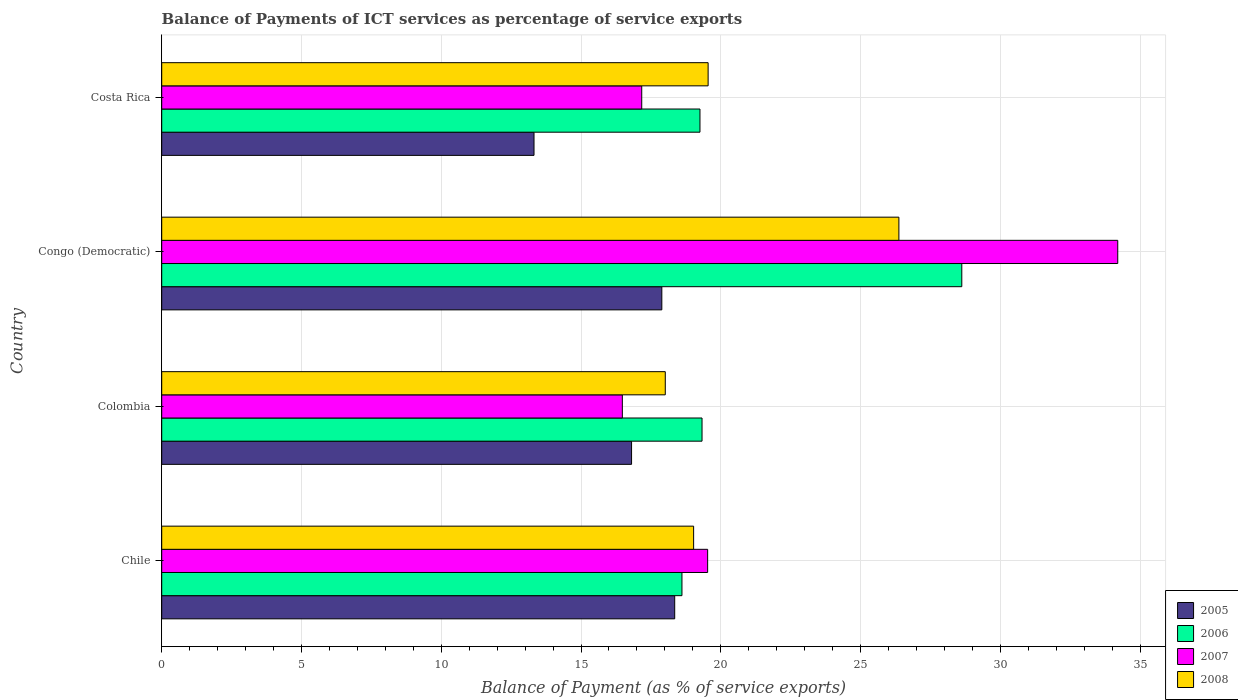How many groups of bars are there?
Give a very brief answer. 4. Are the number of bars per tick equal to the number of legend labels?
Provide a succinct answer. Yes. Are the number of bars on each tick of the Y-axis equal?
Offer a very short reply. Yes. How many bars are there on the 2nd tick from the bottom?
Provide a short and direct response. 4. What is the label of the 2nd group of bars from the top?
Your answer should be very brief. Congo (Democratic). In how many cases, is the number of bars for a given country not equal to the number of legend labels?
Your response must be concise. 0. What is the balance of payments of ICT services in 2006 in Colombia?
Offer a terse response. 19.33. Across all countries, what is the maximum balance of payments of ICT services in 2008?
Provide a succinct answer. 26.37. Across all countries, what is the minimum balance of payments of ICT services in 2008?
Offer a terse response. 18.01. In which country was the balance of payments of ICT services in 2006 maximum?
Offer a terse response. Congo (Democratic). What is the total balance of payments of ICT services in 2005 in the graph?
Provide a short and direct response. 66.37. What is the difference between the balance of payments of ICT services in 2008 in Chile and that in Congo (Democratic)?
Provide a succinct answer. -7.34. What is the difference between the balance of payments of ICT services in 2005 in Congo (Democratic) and the balance of payments of ICT services in 2006 in Costa Rica?
Your answer should be very brief. -1.36. What is the average balance of payments of ICT services in 2007 per country?
Provide a succinct answer. 21.84. What is the difference between the balance of payments of ICT services in 2005 and balance of payments of ICT services in 2006 in Congo (Democratic)?
Your answer should be very brief. -10.73. What is the ratio of the balance of payments of ICT services in 2006 in Chile to that in Costa Rica?
Ensure brevity in your answer.  0.97. Is the balance of payments of ICT services in 2008 in Congo (Democratic) less than that in Costa Rica?
Provide a short and direct response. No. What is the difference between the highest and the second highest balance of payments of ICT services in 2007?
Provide a succinct answer. 14.67. What is the difference between the highest and the lowest balance of payments of ICT services in 2008?
Offer a very short reply. 8.36. In how many countries, is the balance of payments of ICT services in 2008 greater than the average balance of payments of ICT services in 2008 taken over all countries?
Offer a terse response. 1. Is the sum of the balance of payments of ICT services in 2008 in Chile and Colombia greater than the maximum balance of payments of ICT services in 2007 across all countries?
Keep it short and to the point. Yes. What does the 1st bar from the top in Congo (Democratic) represents?
Make the answer very short. 2008. What does the 3rd bar from the bottom in Colombia represents?
Give a very brief answer. 2007. How many bars are there?
Provide a succinct answer. 16. Are all the bars in the graph horizontal?
Keep it short and to the point. Yes. How many countries are there in the graph?
Offer a very short reply. 4. Are the values on the major ticks of X-axis written in scientific E-notation?
Make the answer very short. No. Does the graph contain any zero values?
Your answer should be very brief. No. How many legend labels are there?
Keep it short and to the point. 4. What is the title of the graph?
Keep it short and to the point. Balance of Payments of ICT services as percentage of service exports. What is the label or title of the X-axis?
Keep it short and to the point. Balance of Payment (as % of service exports). What is the Balance of Payment (as % of service exports) of 2005 in Chile?
Offer a very short reply. 18.35. What is the Balance of Payment (as % of service exports) in 2006 in Chile?
Provide a succinct answer. 18.61. What is the Balance of Payment (as % of service exports) in 2007 in Chile?
Provide a succinct answer. 19.53. What is the Balance of Payment (as % of service exports) in 2008 in Chile?
Provide a short and direct response. 19.03. What is the Balance of Payment (as % of service exports) of 2005 in Colombia?
Provide a succinct answer. 16.81. What is the Balance of Payment (as % of service exports) in 2006 in Colombia?
Provide a short and direct response. 19.33. What is the Balance of Payment (as % of service exports) in 2007 in Colombia?
Provide a succinct answer. 16.48. What is the Balance of Payment (as % of service exports) of 2008 in Colombia?
Offer a very short reply. 18.01. What is the Balance of Payment (as % of service exports) of 2005 in Congo (Democratic)?
Offer a terse response. 17.89. What is the Balance of Payment (as % of service exports) in 2006 in Congo (Democratic)?
Your response must be concise. 28.62. What is the Balance of Payment (as % of service exports) in 2007 in Congo (Democratic)?
Provide a short and direct response. 34.2. What is the Balance of Payment (as % of service exports) in 2008 in Congo (Democratic)?
Your answer should be very brief. 26.37. What is the Balance of Payment (as % of service exports) in 2005 in Costa Rica?
Your response must be concise. 13.32. What is the Balance of Payment (as % of service exports) of 2006 in Costa Rica?
Ensure brevity in your answer.  19.25. What is the Balance of Payment (as % of service exports) in 2007 in Costa Rica?
Your response must be concise. 17.17. What is the Balance of Payment (as % of service exports) in 2008 in Costa Rica?
Provide a short and direct response. 19.55. Across all countries, what is the maximum Balance of Payment (as % of service exports) in 2005?
Ensure brevity in your answer.  18.35. Across all countries, what is the maximum Balance of Payment (as % of service exports) in 2006?
Your response must be concise. 28.62. Across all countries, what is the maximum Balance of Payment (as % of service exports) of 2007?
Ensure brevity in your answer.  34.2. Across all countries, what is the maximum Balance of Payment (as % of service exports) of 2008?
Your answer should be very brief. 26.37. Across all countries, what is the minimum Balance of Payment (as % of service exports) in 2005?
Your answer should be compact. 13.32. Across all countries, what is the minimum Balance of Payment (as % of service exports) in 2006?
Give a very brief answer. 18.61. Across all countries, what is the minimum Balance of Payment (as % of service exports) of 2007?
Ensure brevity in your answer.  16.48. Across all countries, what is the minimum Balance of Payment (as % of service exports) in 2008?
Offer a terse response. 18.01. What is the total Balance of Payment (as % of service exports) of 2005 in the graph?
Keep it short and to the point. 66.37. What is the total Balance of Payment (as % of service exports) of 2006 in the graph?
Keep it short and to the point. 85.81. What is the total Balance of Payment (as % of service exports) in 2007 in the graph?
Offer a very short reply. 87.38. What is the total Balance of Payment (as % of service exports) in 2008 in the graph?
Keep it short and to the point. 82.96. What is the difference between the Balance of Payment (as % of service exports) of 2005 in Chile and that in Colombia?
Make the answer very short. 1.54. What is the difference between the Balance of Payment (as % of service exports) of 2006 in Chile and that in Colombia?
Your response must be concise. -0.72. What is the difference between the Balance of Payment (as % of service exports) in 2007 in Chile and that in Colombia?
Offer a terse response. 3.05. What is the difference between the Balance of Payment (as % of service exports) of 2008 in Chile and that in Colombia?
Keep it short and to the point. 1.01. What is the difference between the Balance of Payment (as % of service exports) of 2005 in Chile and that in Congo (Democratic)?
Make the answer very short. 0.46. What is the difference between the Balance of Payment (as % of service exports) of 2006 in Chile and that in Congo (Democratic)?
Your response must be concise. -10.01. What is the difference between the Balance of Payment (as % of service exports) in 2007 in Chile and that in Congo (Democratic)?
Keep it short and to the point. -14.67. What is the difference between the Balance of Payment (as % of service exports) of 2008 in Chile and that in Congo (Democratic)?
Ensure brevity in your answer.  -7.34. What is the difference between the Balance of Payment (as % of service exports) in 2005 in Chile and that in Costa Rica?
Your answer should be compact. 5.03. What is the difference between the Balance of Payment (as % of service exports) of 2006 in Chile and that in Costa Rica?
Ensure brevity in your answer.  -0.64. What is the difference between the Balance of Payment (as % of service exports) of 2007 in Chile and that in Costa Rica?
Give a very brief answer. 2.36. What is the difference between the Balance of Payment (as % of service exports) of 2008 in Chile and that in Costa Rica?
Your answer should be compact. -0.52. What is the difference between the Balance of Payment (as % of service exports) of 2005 in Colombia and that in Congo (Democratic)?
Provide a succinct answer. -1.08. What is the difference between the Balance of Payment (as % of service exports) of 2006 in Colombia and that in Congo (Democratic)?
Offer a terse response. -9.29. What is the difference between the Balance of Payment (as % of service exports) of 2007 in Colombia and that in Congo (Democratic)?
Provide a short and direct response. -17.72. What is the difference between the Balance of Payment (as % of service exports) of 2008 in Colombia and that in Congo (Democratic)?
Give a very brief answer. -8.36. What is the difference between the Balance of Payment (as % of service exports) in 2005 in Colombia and that in Costa Rica?
Ensure brevity in your answer.  3.49. What is the difference between the Balance of Payment (as % of service exports) of 2006 in Colombia and that in Costa Rica?
Your answer should be very brief. 0.07. What is the difference between the Balance of Payment (as % of service exports) in 2007 in Colombia and that in Costa Rica?
Your response must be concise. -0.69. What is the difference between the Balance of Payment (as % of service exports) in 2008 in Colombia and that in Costa Rica?
Provide a succinct answer. -1.53. What is the difference between the Balance of Payment (as % of service exports) of 2005 in Congo (Democratic) and that in Costa Rica?
Make the answer very short. 4.57. What is the difference between the Balance of Payment (as % of service exports) of 2006 in Congo (Democratic) and that in Costa Rica?
Offer a very short reply. 9.37. What is the difference between the Balance of Payment (as % of service exports) of 2007 in Congo (Democratic) and that in Costa Rica?
Ensure brevity in your answer.  17.03. What is the difference between the Balance of Payment (as % of service exports) of 2008 in Congo (Democratic) and that in Costa Rica?
Your answer should be very brief. 6.82. What is the difference between the Balance of Payment (as % of service exports) in 2005 in Chile and the Balance of Payment (as % of service exports) in 2006 in Colombia?
Your answer should be very brief. -0.98. What is the difference between the Balance of Payment (as % of service exports) in 2005 in Chile and the Balance of Payment (as % of service exports) in 2007 in Colombia?
Provide a succinct answer. 1.87. What is the difference between the Balance of Payment (as % of service exports) in 2005 in Chile and the Balance of Payment (as % of service exports) in 2008 in Colombia?
Your answer should be compact. 0.34. What is the difference between the Balance of Payment (as % of service exports) of 2006 in Chile and the Balance of Payment (as % of service exports) of 2007 in Colombia?
Provide a short and direct response. 2.13. What is the difference between the Balance of Payment (as % of service exports) of 2006 in Chile and the Balance of Payment (as % of service exports) of 2008 in Colombia?
Ensure brevity in your answer.  0.6. What is the difference between the Balance of Payment (as % of service exports) in 2007 in Chile and the Balance of Payment (as % of service exports) in 2008 in Colombia?
Provide a succinct answer. 1.52. What is the difference between the Balance of Payment (as % of service exports) of 2005 in Chile and the Balance of Payment (as % of service exports) of 2006 in Congo (Democratic)?
Make the answer very short. -10.27. What is the difference between the Balance of Payment (as % of service exports) in 2005 in Chile and the Balance of Payment (as % of service exports) in 2007 in Congo (Democratic)?
Your response must be concise. -15.85. What is the difference between the Balance of Payment (as % of service exports) of 2005 in Chile and the Balance of Payment (as % of service exports) of 2008 in Congo (Democratic)?
Offer a terse response. -8.02. What is the difference between the Balance of Payment (as % of service exports) in 2006 in Chile and the Balance of Payment (as % of service exports) in 2007 in Congo (Democratic)?
Offer a very short reply. -15.59. What is the difference between the Balance of Payment (as % of service exports) in 2006 in Chile and the Balance of Payment (as % of service exports) in 2008 in Congo (Democratic)?
Ensure brevity in your answer.  -7.76. What is the difference between the Balance of Payment (as % of service exports) of 2007 in Chile and the Balance of Payment (as % of service exports) of 2008 in Congo (Democratic)?
Keep it short and to the point. -6.84. What is the difference between the Balance of Payment (as % of service exports) of 2005 in Chile and the Balance of Payment (as % of service exports) of 2006 in Costa Rica?
Offer a terse response. -0.9. What is the difference between the Balance of Payment (as % of service exports) in 2005 in Chile and the Balance of Payment (as % of service exports) in 2007 in Costa Rica?
Make the answer very short. 1.18. What is the difference between the Balance of Payment (as % of service exports) of 2005 in Chile and the Balance of Payment (as % of service exports) of 2008 in Costa Rica?
Make the answer very short. -1.2. What is the difference between the Balance of Payment (as % of service exports) of 2006 in Chile and the Balance of Payment (as % of service exports) of 2007 in Costa Rica?
Give a very brief answer. 1.44. What is the difference between the Balance of Payment (as % of service exports) of 2006 in Chile and the Balance of Payment (as % of service exports) of 2008 in Costa Rica?
Provide a short and direct response. -0.94. What is the difference between the Balance of Payment (as % of service exports) in 2007 in Chile and the Balance of Payment (as % of service exports) in 2008 in Costa Rica?
Offer a very short reply. -0.02. What is the difference between the Balance of Payment (as % of service exports) in 2005 in Colombia and the Balance of Payment (as % of service exports) in 2006 in Congo (Democratic)?
Your answer should be compact. -11.81. What is the difference between the Balance of Payment (as % of service exports) in 2005 in Colombia and the Balance of Payment (as % of service exports) in 2007 in Congo (Democratic)?
Give a very brief answer. -17.39. What is the difference between the Balance of Payment (as % of service exports) of 2005 in Colombia and the Balance of Payment (as % of service exports) of 2008 in Congo (Democratic)?
Your response must be concise. -9.56. What is the difference between the Balance of Payment (as % of service exports) of 2006 in Colombia and the Balance of Payment (as % of service exports) of 2007 in Congo (Democratic)?
Offer a terse response. -14.87. What is the difference between the Balance of Payment (as % of service exports) in 2006 in Colombia and the Balance of Payment (as % of service exports) in 2008 in Congo (Democratic)?
Ensure brevity in your answer.  -7.04. What is the difference between the Balance of Payment (as % of service exports) of 2007 in Colombia and the Balance of Payment (as % of service exports) of 2008 in Congo (Democratic)?
Offer a very short reply. -9.89. What is the difference between the Balance of Payment (as % of service exports) of 2005 in Colombia and the Balance of Payment (as % of service exports) of 2006 in Costa Rica?
Your answer should be very brief. -2.45. What is the difference between the Balance of Payment (as % of service exports) in 2005 in Colombia and the Balance of Payment (as % of service exports) in 2007 in Costa Rica?
Offer a terse response. -0.36. What is the difference between the Balance of Payment (as % of service exports) in 2005 in Colombia and the Balance of Payment (as % of service exports) in 2008 in Costa Rica?
Ensure brevity in your answer.  -2.74. What is the difference between the Balance of Payment (as % of service exports) in 2006 in Colombia and the Balance of Payment (as % of service exports) in 2007 in Costa Rica?
Your answer should be very brief. 2.16. What is the difference between the Balance of Payment (as % of service exports) in 2006 in Colombia and the Balance of Payment (as % of service exports) in 2008 in Costa Rica?
Your response must be concise. -0.22. What is the difference between the Balance of Payment (as % of service exports) in 2007 in Colombia and the Balance of Payment (as % of service exports) in 2008 in Costa Rica?
Give a very brief answer. -3.07. What is the difference between the Balance of Payment (as % of service exports) of 2005 in Congo (Democratic) and the Balance of Payment (as % of service exports) of 2006 in Costa Rica?
Your answer should be very brief. -1.36. What is the difference between the Balance of Payment (as % of service exports) of 2005 in Congo (Democratic) and the Balance of Payment (as % of service exports) of 2007 in Costa Rica?
Keep it short and to the point. 0.72. What is the difference between the Balance of Payment (as % of service exports) of 2005 in Congo (Democratic) and the Balance of Payment (as % of service exports) of 2008 in Costa Rica?
Make the answer very short. -1.66. What is the difference between the Balance of Payment (as % of service exports) of 2006 in Congo (Democratic) and the Balance of Payment (as % of service exports) of 2007 in Costa Rica?
Keep it short and to the point. 11.45. What is the difference between the Balance of Payment (as % of service exports) in 2006 in Congo (Democratic) and the Balance of Payment (as % of service exports) in 2008 in Costa Rica?
Keep it short and to the point. 9.07. What is the difference between the Balance of Payment (as % of service exports) in 2007 in Congo (Democratic) and the Balance of Payment (as % of service exports) in 2008 in Costa Rica?
Offer a terse response. 14.65. What is the average Balance of Payment (as % of service exports) of 2005 per country?
Your answer should be compact. 16.59. What is the average Balance of Payment (as % of service exports) in 2006 per country?
Provide a succinct answer. 21.45. What is the average Balance of Payment (as % of service exports) of 2007 per country?
Offer a terse response. 21.84. What is the average Balance of Payment (as % of service exports) in 2008 per country?
Provide a short and direct response. 20.74. What is the difference between the Balance of Payment (as % of service exports) in 2005 and Balance of Payment (as % of service exports) in 2006 in Chile?
Make the answer very short. -0.26. What is the difference between the Balance of Payment (as % of service exports) in 2005 and Balance of Payment (as % of service exports) in 2007 in Chile?
Provide a short and direct response. -1.18. What is the difference between the Balance of Payment (as % of service exports) in 2005 and Balance of Payment (as % of service exports) in 2008 in Chile?
Make the answer very short. -0.68. What is the difference between the Balance of Payment (as % of service exports) of 2006 and Balance of Payment (as % of service exports) of 2007 in Chile?
Your answer should be compact. -0.92. What is the difference between the Balance of Payment (as % of service exports) of 2006 and Balance of Payment (as % of service exports) of 2008 in Chile?
Offer a terse response. -0.42. What is the difference between the Balance of Payment (as % of service exports) of 2007 and Balance of Payment (as % of service exports) of 2008 in Chile?
Offer a terse response. 0.5. What is the difference between the Balance of Payment (as % of service exports) of 2005 and Balance of Payment (as % of service exports) of 2006 in Colombia?
Give a very brief answer. -2.52. What is the difference between the Balance of Payment (as % of service exports) in 2005 and Balance of Payment (as % of service exports) in 2007 in Colombia?
Ensure brevity in your answer.  0.33. What is the difference between the Balance of Payment (as % of service exports) of 2005 and Balance of Payment (as % of service exports) of 2008 in Colombia?
Your answer should be compact. -1.21. What is the difference between the Balance of Payment (as % of service exports) in 2006 and Balance of Payment (as % of service exports) in 2007 in Colombia?
Provide a succinct answer. 2.85. What is the difference between the Balance of Payment (as % of service exports) of 2006 and Balance of Payment (as % of service exports) of 2008 in Colombia?
Offer a very short reply. 1.32. What is the difference between the Balance of Payment (as % of service exports) in 2007 and Balance of Payment (as % of service exports) in 2008 in Colombia?
Provide a short and direct response. -1.54. What is the difference between the Balance of Payment (as % of service exports) of 2005 and Balance of Payment (as % of service exports) of 2006 in Congo (Democratic)?
Keep it short and to the point. -10.73. What is the difference between the Balance of Payment (as % of service exports) in 2005 and Balance of Payment (as % of service exports) in 2007 in Congo (Democratic)?
Keep it short and to the point. -16.31. What is the difference between the Balance of Payment (as % of service exports) of 2005 and Balance of Payment (as % of service exports) of 2008 in Congo (Democratic)?
Your answer should be very brief. -8.48. What is the difference between the Balance of Payment (as % of service exports) of 2006 and Balance of Payment (as % of service exports) of 2007 in Congo (Democratic)?
Ensure brevity in your answer.  -5.58. What is the difference between the Balance of Payment (as % of service exports) in 2006 and Balance of Payment (as % of service exports) in 2008 in Congo (Democratic)?
Ensure brevity in your answer.  2.25. What is the difference between the Balance of Payment (as % of service exports) of 2007 and Balance of Payment (as % of service exports) of 2008 in Congo (Democratic)?
Give a very brief answer. 7.83. What is the difference between the Balance of Payment (as % of service exports) in 2005 and Balance of Payment (as % of service exports) in 2006 in Costa Rica?
Your response must be concise. -5.94. What is the difference between the Balance of Payment (as % of service exports) of 2005 and Balance of Payment (as % of service exports) of 2007 in Costa Rica?
Provide a short and direct response. -3.85. What is the difference between the Balance of Payment (as % of service exports) of 2005 and Balance of Payment (as % of service exports) of 2008 in Costa Rica?
Offer a very short reply. -6.23. What is the difference between the Balance of Payment (as % of service exports) in 2006 and Balance of Payment (as % of service exports) in 2007 in Costa Rica?
Keep it short and to the point. 2.08. What is the difference between the Balance of Payment (as % of service exports) of 2006 and Balance of Payment (as % of service exports) of 2008 in Costa Rica?
Offer a very short reply. -0.29. What is the difference between the Balance of Payment (as % of service exports) in 2007 and Balance of Payment (as % of service exports) in 2008 in Costa Rica?
Provide a succinct answer. -2.38. What is the ratio of the Balance of Payment (as % of service exports) of 2005 in Chile to that in Colombia?
Offer a terse response. 1.09. What is the ratio of the Balance of Payment (as % of service exports) in 2006 in Chile to that in Colombia?
Make the answer very short. 0.96. What is the ratio of the Balance of Payment (as % of service exports) of 2007 in Chile to that in Colombia?
Provide a short and direct response. 1.19. What is the ratio of the Balance of Payment (as % of service exports) of 2008 in Chile to that in Colombia?
Provide a succinct answer. 1.06. What is the ratio of the Balance of Payment (as % of service exports) of 2005 in Chile to that in Congo (Democratic)?
Provide a short and direct response. 1.03. What is the ratio of the Balance of Payment (as % of service exports) in 2006 in Chile to that in Congo (Democratic)?
Provide a succinct answer. 0.65. What is the ratio of the Balance of Payment (as % of service exports) of 2007 in Chile to that in Congo (Democratic)?
Offer a very short reply. 0.57. What is the ratio of the Balance of Payment (as % of service exports) in 2008 in Chile to that in Congo (Democratic)?
Offer a very short reply. 0.72. What is the ratio of the Balance of Payment (as % of service exports) of 2005 in Chile to that in Costa Rica?
Make the answer very short. 1.38. What is the ratio of the Balance of Payment (as % of service exports) in 2006 in Chile to that in Costa Rica?
Offer a terse response. 0.97. What is the ratio of the Balance of Payment (as % of service exports) of 2007 in Chile to that in Costa Rica?
Your answer should be very brief. 1.14. What is the ratio of the Balance of Payment (as % of service exports) in 2008 in Chile to that in Costa Rica?
Provide a short and direct response. 0.97. What is the ratio of the Balance of Payment (as % of service exports) in 2005 in Colombia to that in Congo (Democratic)?
Keep it short and to the point. 0.94. What is the ratio of the Balance of Payment (as % of service exports) of 2006 in Colombia to that in Congo (Democratic)?
Make the answer very short. 0.68. What is the ratio of the Balance of Payment (as % of service exports) in 2007 in Colombia to that in Congo (Democratic)?
Ensure brevity in your answer.  0.48. What is the ratio of the Balance of Payment (as % of service exports) in 2008 in Colombia to that in Congo (Democratic)?
Your answer should be compact. 0.68. What is the ratio of the Balance of Payment (as % of service exports) in 2005 in Colombia to that in Costa Rica?
Your answer should be compact. 1.26. What is the ratio of the Balance of Payment (as % of service exports) of 2007 in Colombia to that in Costa Rica?
Offer a very short reply. 0.96. What is the ratio of the Balance of Payment (as % of service exports) of 2008 in Colombia to that in Costa Rica?
Ensure brevity in your answer.  0.92. What is the ratio of the Balance of Payment (as % of service exports) of 2005 in Congo (Democratic) to that in Costa Rica?
Offer a terse response. 1.34. What is the ratio of the Balance of Payment (as % of service exports) in 2006 in Congo (Democratic) to that in Costa Rica?
Your answer should be compact. 1.49. What is the ratio of the Balance of Payment (as % of service exports) of 2007 in Congo (Democratic) to that in Costa Rica?
Offer a very short reply. 1.99. What is the ratio of the Balance of Payment (as % of service exports) of 2008 in Congo (Democratic) to that in Costa Rica?
Your response must be concise. 1.35. What is the difference between the highest and the second highest Balance of Payment (as % of service exports) of 2005?
Offer a very short reply. 0.46. What is the difference between the highest and the second highest Balance of Payment (as % of service exports) in 2006?
Offer a terse response. 9.29. What is the difference between the highest and the second highest Balance of Payment (as % of service exports) of 2007?
Your answer should be very brief. 14.67. What is the difference between the highest and the second highest Balance of Payment (as % of service exports) in 2008?
Give a very brief answer. 6.82. What is the difference between the highest and the lowest Balance of Payment (as % of service exports) of 2005?
Make the answer very short. 5.03. What is the difference between the highest and the lowest Balance of Payment (as % of service exports) in 2006?
Offer a very short reply. 10.01. What is the difference between the highest and the lowest Balance of Payment (as % of service exports) in 2007?
Give a very brief answer. 17.72. What is the difference between the highest and the lowest Balance of Payment (as % of service exports) of 2008?
Make the answer very short. 8.36. 